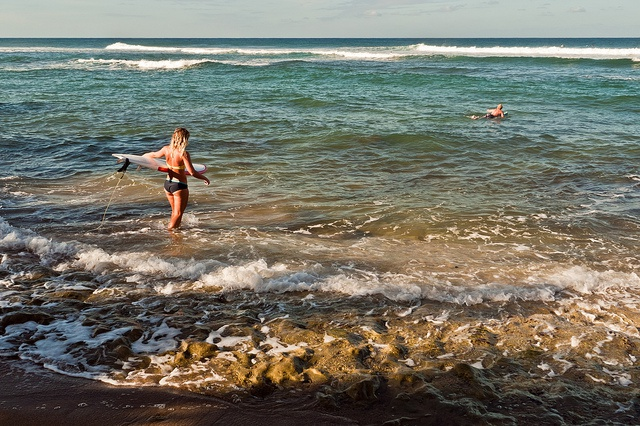Describe the objects in this image and their specific colors. I can see people in lightgray, black, maroon, salmon, and tan tones, surfboard in lightgray, darkgray, tan, and black tones, people in lightgray, gray, tan, and salmon tones, and surfboard in lightgray, darkgray, teal, beige, and turquoise tones in this image. 